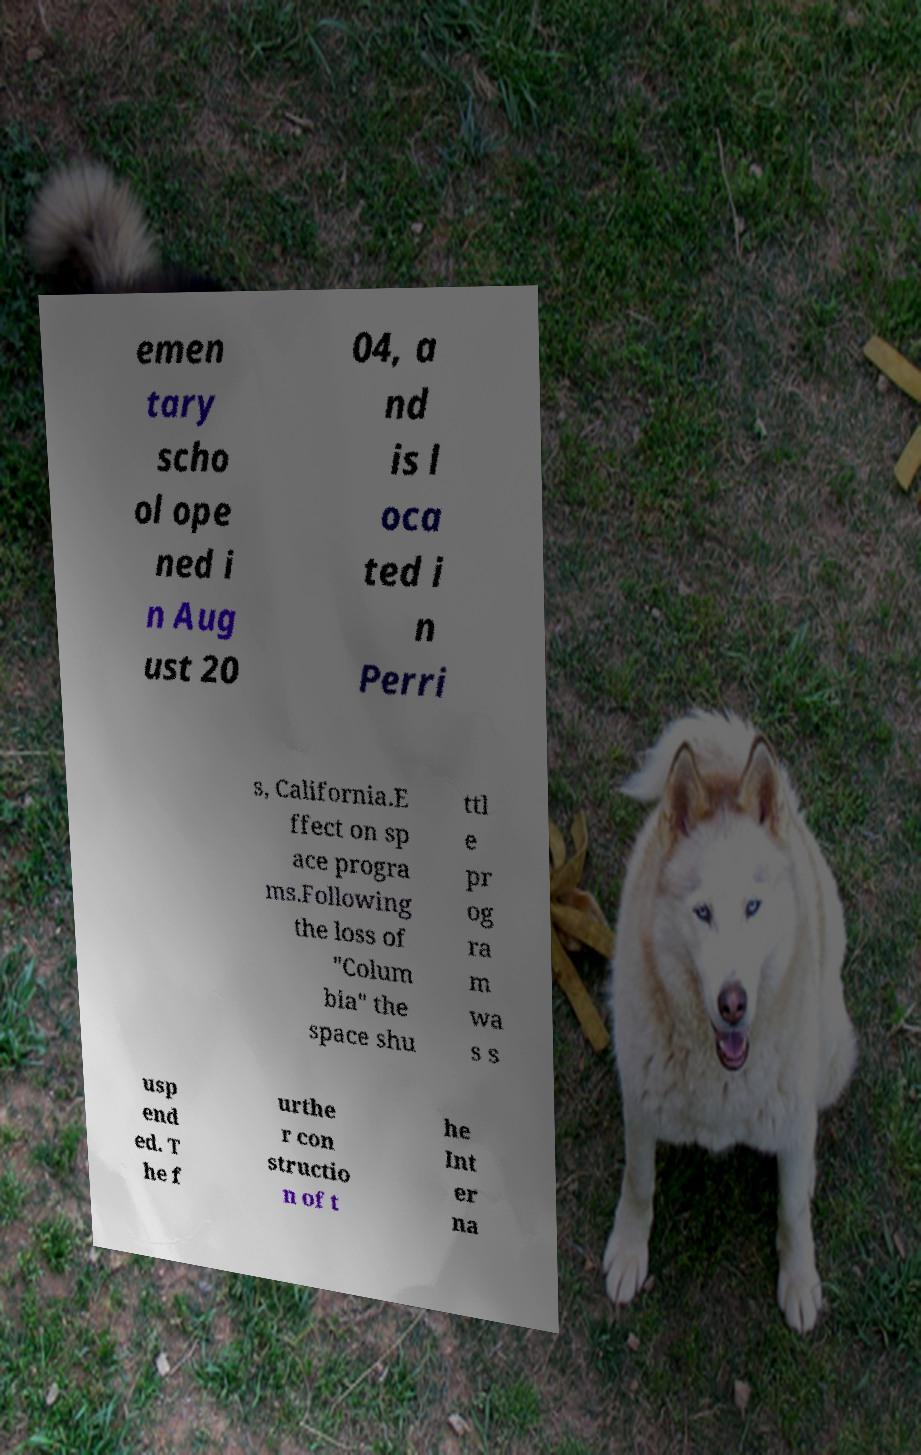There's text embedded in this image that I need extracted. Can you transcribe it verbatim? emen tary scho ol ope ned i n Aug ust 20 04, a nd is l oca ted i n Perri s, California.E ffect on sp ace progra ms.Following the loss of "Colum bia" the space shu ttl e pr og ra m wa s s usp end ed. T he f urthe r con structio n of t he Int er na 